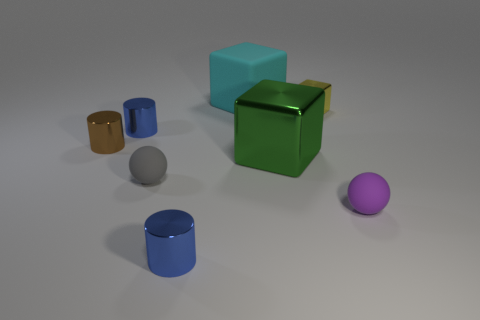What color is the other matte thing that is the same shape as the gray matte thing?
Provide a short and direct response. Purple. Does the brown shiny cylinder in front of the yellow object have the same size as the matte object behind the green object?
Your answer should be compact. No. Does the small gray thing have the same shape as the small purple matte object?
Your answer should be very brief. Yes. How many objects are either tiny shiny things that are behind the small brown metallic cylinder or small yellow cubes?
Offer a terse response. 2. Are there any green metal things that have the same shape as the yellow metallic object?
Your response must be concise. Yes. Are there an equal number of tiny gray balls right of the yellow metallic block and tiny objects?
Your answer should be compact. No. How many brown cylinders are the same size as the brown thing?
Ensure brevity in your answer.  0. How many tiny purple rubber balls are on the left side of the large rubber block?
Offer a very short reply. 0. What material is the gray thing that is left of the block in front of the small brown metal cylinder?
Offer a very short reply. Rubber. Are there any rubber spheres of the same color as the small block?
Keep it short and to the point. No. 